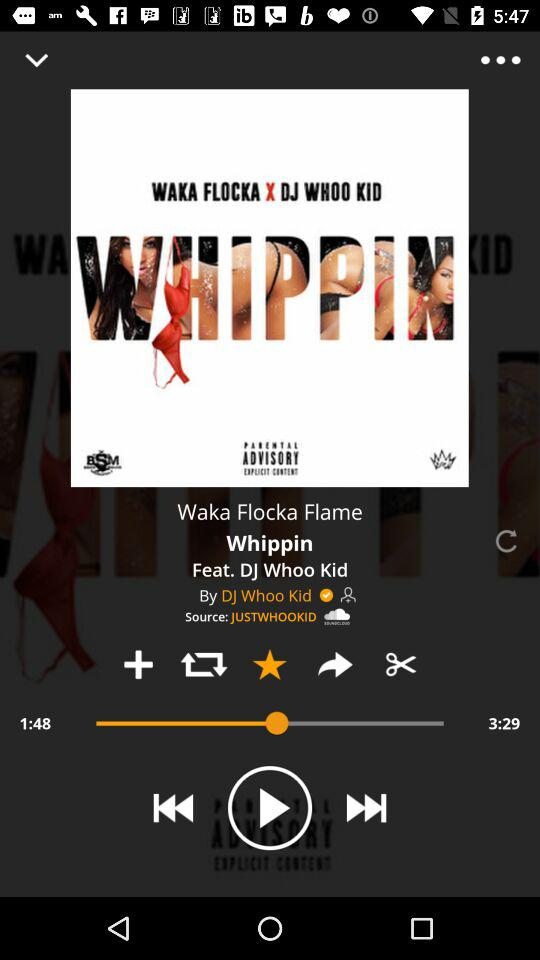What is the given source? The given source is "JUSTWHOOKID". 